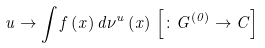Convert formula to latex. <formula><loc_0><loc_0><loc_500><loc_500>u \rightarrow \int f \left ( x \right ) d \nu ^ { u } \left ( x \right ) \, \left [ \colon G ^ { \left ( 0 \right ) } \rightarrow C \right ]</formula> 